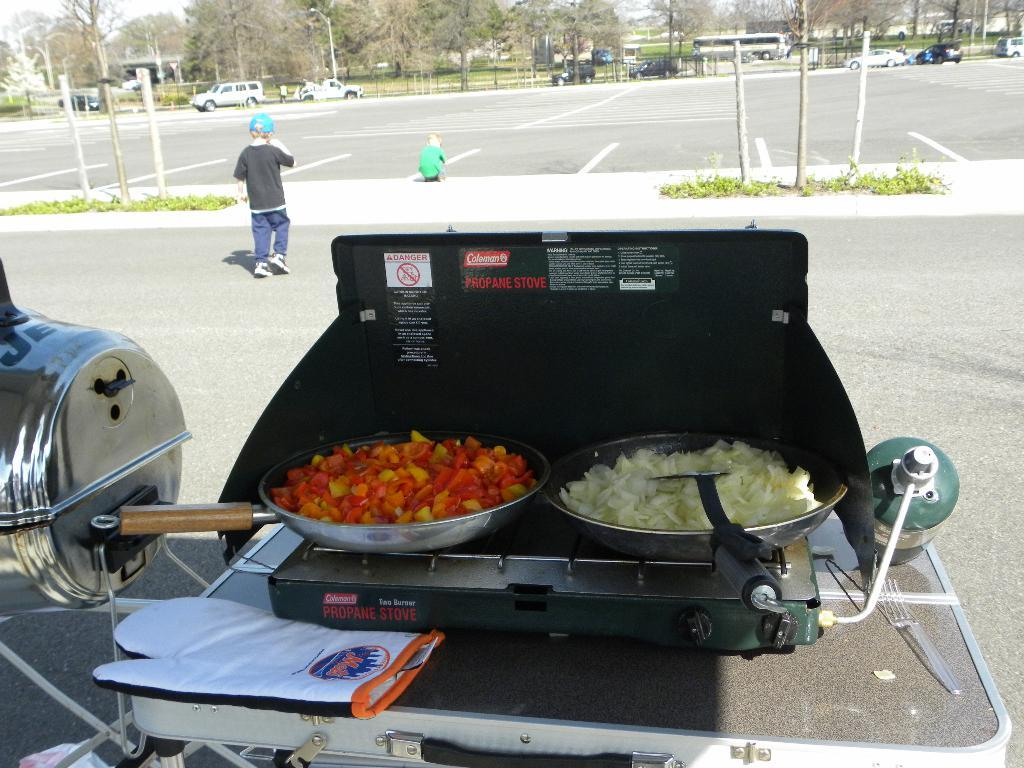Provide a one-sentence caption for the provided image. a propane stove with a lot of food on it. 